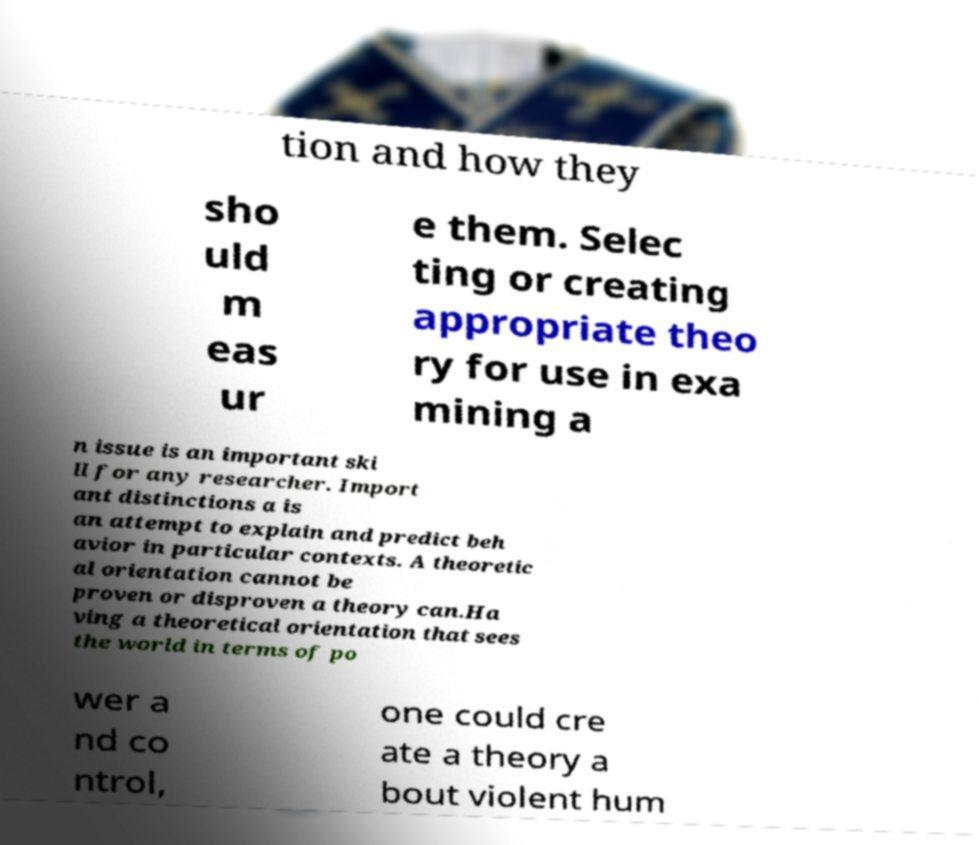Could you extract and type out the text from this image? tion and how they sho uld m eas ur e them. Selec ting or creating appropriate theo ry for use in exa mining a n issue is an important ski ll for any researcher. Import ant distinctions a is an attempt to explain and predict beh avior in particular contexts. A theoretic al orientation cannot be proven or disproven a theory can.Ha ving a theoretical orientation that sees the world in terms of po wer a nd co ntrol, one could cre ate a theory a bout violent hum 